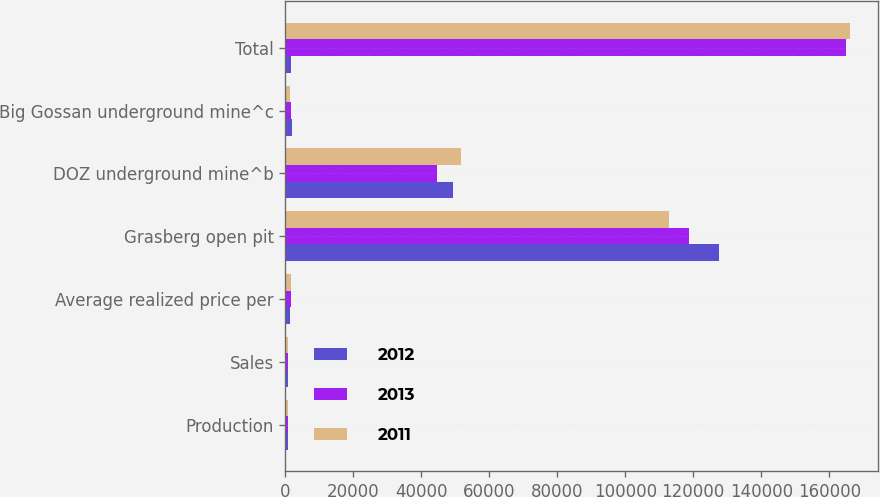<chart> <loc_0><loc_0><loc_500><loc_500><stacked_bar_chart><ecel><fcel>Production<fcel>Sales<fcel>Average realized price per<fcel>Grasberg open pit<fcel>DOZ underground mine^b<fcel>Big Gossan underground mine^c<fcel>Total<nl><fcel>2012<fcel>915<fcel>885<fcel>1312<fcel>127700<fcel>49400<fcel>2100<fcel>1583<nl><fcel>2013<fcel>695<fcel>716<fcel>1664<fcel>118800<fcel>44600<fcel>1600<fcel>165000<nl><fcel>2011<fcel>846<fcel>846<fcel>1583<fcel>112900<fcel>51700<fcel>1500<fcel>166100<nl></chart> 